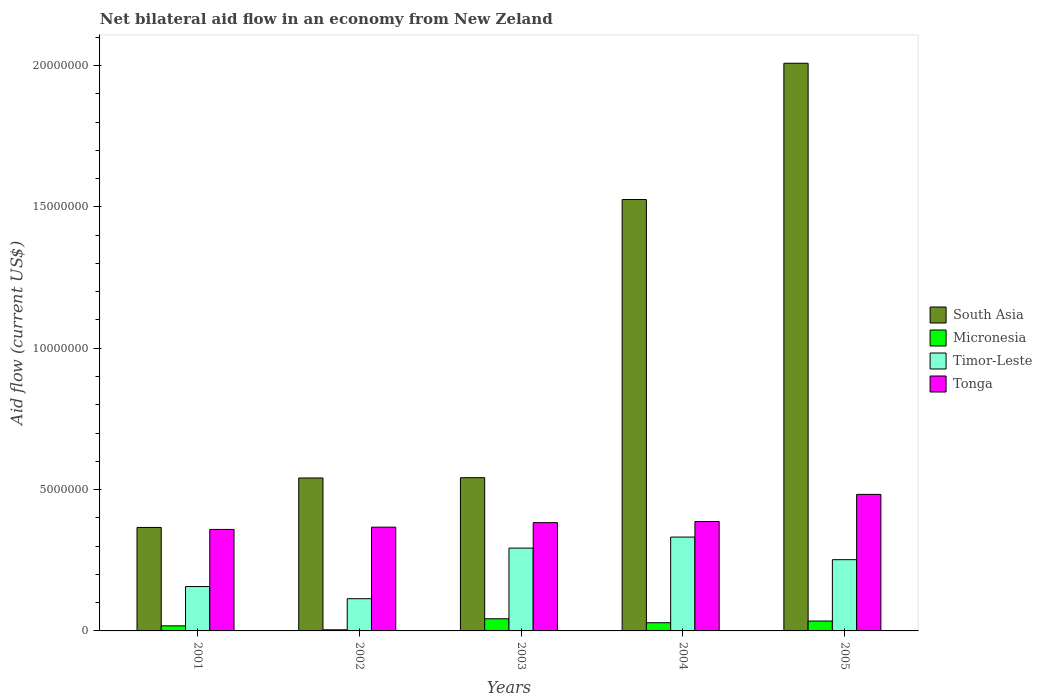How many different coloured bars are there?
Keep it short and to the point. 4. Are the number of bars per tick equal to the number of legend labels?
Keep it short and to the point. Yes. Are the number of bars on each tick of the X-axis equal?
Your answer should be compact. Yes. What is the net bilateral aid flow in South Asia in 2004?
Offer a very short reply. 1.53e+07. Across all years, what is the maximum net bilateral aid flow in South Asia?
Your answer should be very brief. 2.01e+07. Across all years, what is the minimum net bilateral aid flow in Micronesia?
Offer a very short reply. 4.00e+04. In which year was the net bilateral aid flow in Tonga maximum?
Provide a succinct answer. 2005. What is the total net bilateral aid flow in Micronesia in the graph?
Provide a succinct answer. 1.29e+06. What is the difference between the net bilateral aid flow in Tonga in 2002 and that in 2005?
Give a very brief answer. -1.16e+06. What is the difference between the net bilateral aid flow in Timor-Leste in 2001 and the net bilateral aid flow in Tonga in 2002?
Offer a very short reply. -2.10e+06. What is the average net bilateral aid flow in Tonga per year?
Keep it short and to the point. 3.96e+06. In the year 2005, what is the difference between the net bilateral aid flow in South Asia and net bilateral aid flow in Micronesia?
Provide a short and direct response. 1.97e+07. In how many years, is the net bilateral aid flow in Micronesia greater than 20000000 US$?
Your answer should be compact. 0. What is the ratio of the net bilateral aid flow in Tonga in 2001 to that in 2002?
Provide a succinct answer. 0.98. Is the net bilateral aid flow in Timor-Leste in 2001 less than that in 2003?
Provide a short and direct response. Yes. What is the difference between the highest and the second highest net bilateral aid flow in South Asia?
Provide a short and direct response. 4.82e+06. What is the difference between the highest and the lowest net bilateral aid flow in Tonga?
Make the answer very short. 1.24e+06. What does the 3rd bar from the left in 2003 represents?
Ensure brevity in your answer.  Timor-Leste. Is it the case that in every year, the sum of the net bilateral aid flow in South Asia and net bilateral aid flow in Tonga is greater than the net bilateral aid flow in Micronesia?
Provide a succinct answer. Yes. Are all the bars in the graph horizontal?
Your answer should be very brief. No. How many years are there in the graph?
Your response must be concise. 5. Are the values on the major ticks of Y-axis written in scientific E-notation?
Provide a succinct answer. No. How are the legend labels stacked?
Your answer should be compact. Vertical. What is the title of the graph?
Keep it short and to the point. Net bilateral aid flow in an economy from New Zeland. What is the label or title of the Y-axis?
Your answer should be very brief. Aid flow (current US$). What is the Aid flow (current US$) in South Asia in 2001?
Keep it short and to the point. 3.66e+06. What is the Aid flow (current US$) of Micronesia in 2001?
Give a very brief answer. 1.80e+05. What is the Aid flow (current US$) in Timor-Leste in 2001?
Provide a short and direct response. 1.57e+06. What is the Aid flow (current US$) in Tonga in 2001?
Offer a terse response. 3.59e+06. What is the Aid flow (current US$) of South Asia in 2002?
Give a very brief answer. 5.41e+06. What is the Aid flow (current US$) in Micronesia in 2002?
Give a very brief answer. 4.00e+04. What is the Aid flow (current US$) of Timor-Leste in 2002?
Your answer should be compact. 1.14e+06. What is the Aid flow (current US$) in Tonga in 2002?
Provide a succinct answer. 3.67e+06. What is the Aid flow (current US$) in South Asia in 2003?
Provide a short and direct response. 5.42e+06. What is the Aid flow (current US$) in Timor-Leste in 2003?
Make the answer very short. 2.93e+06. What is the Aid flow (current US$) of Tonga in 2003?
Make the answer very short. 3.83e+06. What is the Aid flow (current US$) in South Asia in 2004?
Provide a short and direct response. 1.53e+07. What is the Aid flow (current US$) in Timor-Leste in 2004?
Your answer should be very brief. 3.32e+06. What is the Aid flow (current US$) of Tonga in 2004?
Your answer should be very brief. 3.87e+06. What is the Aid flow (current US$) of South Asia in 2005?
Offer a very short reply. 2.01e+07. What is the Aid flow (current US$) of Timor-Leste in 2005?
Your response must be concise. 2.52e+06. What is the Aid flow (current US$) of Tonga in 2005?
Make the answer very short. 4.83e+06. Across all years, what is the maximum Aid flow (current US$) of South Asia?
Offer a very short reply. 2.01e+07. Across all years, what is the maximum Aid flow (current US$) of Timor-Leste?
Offer a very short reply. 3.32e+06. Across all years, what is the maximum Aid flow (current US$) of Tonga?
Give a very brief answer. 4.83e+06. Across all years, what is the minimum Aid flow (current US$) in South Asia?
Ensure brevity in your answer.  3.66e+06. Across all years, what is the minimum Aid flow (current US$) of Timor-Leste?
Offer a very short reply. 1.14e+06. Across all years, what is the minimum Aid flow (current US$) of Tonga?
Make the answer very short. 3.59e+06. What is the total Aid flow (current US$) of South Asia in the graph?
Your answer should be compact. 4.98e+07. What is the total Aid flow (current US$) of Micronesia in the graph?
Keep it short and to the point. 1.29e+06. What is the total Aid flow (current US$) of Timor-Leste in the graph?
Your answer should be very brief. 1.15e+07. What is the total Aid flow (current US$) of Tonga in the graph?
Offer a very short reply. 1.98e+07. What is the difference between the Aid flow (current US$) in South Asia in 2001 and that in 2002?
Your response must be concise. -1.75e+06. What is the difference between the Aid flow (current US$) of Micronesia in 2001 and that in 2002?
Your response must be concise. 1.40e+05. What is the difference between the Aid flow (current US$) in Tonga in 2001 and that in 2002?
Your answer should be compact. -8.00e+04. What is the difference between the Aid flow (current US$) of South Asia in 2001 and that in 2003?
Your answer should be very brief. -1.76e+06. What is the difference between the Aid flow (current US$) in Timor-Leste in 2001 and that in 2003?
Your answer should be very brief. -1.36e+06. What is the difference between the Aid flow (current US$) in Tonga in 2001 and that in 2003?
Make the answer very short. -2.40e+05. What is the difference between the Aid flow (current US$) of South Asia in 2001 and that in 2004?
Your answer should be compact. -1.16e+07. What is the difference between the Aid flow (current US$) of Micronesia in 2001 and that in 2004?
Give a very brief answer. -1.10e+05. What is the difference between the Aid flow (current US$) in Timor-Leste in 2001 and that in 2004?
Ensure brevity in your answer.  -1.75e+06. What is the difference between the Aid flow (current US$) in Tonga in 2001 and that in 2004?
Your answer should be compact. -2.80e+05. What is the difference between the Aid flow (current US$) in South Asia in 2001 and that in 2005?
Ensure brevity in your answer.  -1.64e+07. What is the difference between the Aid flow (current US$) of Timor-Leste in 2001 and that in 2005?
Provide a succinct answer. -9.50e+05. What is the difference between the Aid flow (current US$) in Tonga in 2001 and that in 2005?
Give a very brief answer. -1.24e+06. What is the difference between the Aid flow (current US$) of Micronesia in 2002 and that in 2003?
Offer a terse response. -3.90e+05. What is the difference between the Aid flow (current US$) of Timor-Leste in 2002 and that in 2003?
Provide a succinct answer. -1.79e+06. What is the difference between the Aid flow (current US$) of South Asia in 2002 and that in 2004?
Make the answer very short. -9.85e+06. What is the difference between the Aid flow (current US$) in Micronesia in 2002 and that in 2004?
Keep it short and to the point. -2.50e+05. What is the difference between the Aid flow (current US$) of Timor-Leste in 2002 and that in 2004?
Give a very brief answer. -2.18e+06. What is the difference between the Aid flow (current US$) in South Asia in 2002 and that in 2005?
Offer a very short reply. -1.47e+07. What is the difference between the Aid flow (current US$) of Micronesia in 2002 and that in 2005?
Make the answer very short. -3.10e+05. What is the difference between the Aid flow (current US$) in Timor-Leste in 2002 and that in 2005?
Offer a very short reply. -1.38e+06. What is the difference between the Aid flow (current US$) in Tonga in 2002 and that in 2005?
Provide a short and direct response. -1.16e+06. What is the difference between the Aid flow (current US$) in South Asia in 2003 and that in 2004?
Your response must be concise. -9.84e+06. What is the difference between the Aid flow (current US$) of Timor-Leste in 2003 and that in 2004?
Your answer should be compact. -3.90e+05. What is the difference between the Aid flow (current US$) of South Asia in 2003 and that in 2005?
Provide a short and direct response. -1.47e+07. What is the difference between the Aid flow (current US$) of Micronesia in 2003 and that in 2005?
Make the answer very short. 8.00e+04. What is the difference between the Aid flow (current US$) of Tonga in 2003 and that in 2005?
Give a very brief answer. -1.00e+06. What is the difference between the Aid flow (current US$) in South Asia in 2004 and that in 2005?
Give a very brief answer. -4.82e+06. What is the difference between the Aid flow (current US$) in Micronesia in 2004 and that in 2005?
Offer a very short reply. -6.00e+04. What is the difference between the Aid flow (current US$) in Timor-Leste in 2004 and that in 2005?
Offer a terse response. 8.00e+05. What is the difference between the Aid flow (current US$) in Tonga in 2004 and that in 2005?
Make the answer very short. -9.60e+05. What is the difference between the Aid flow (current US$) of South Asia in 2001 and the Aid flow (current US$) of Micronesia in 2002?
Offer a very short reply. 3.62e+06. What is the difference between the Aid flow (current US$) in South Asia in 2001 and the Aid flow (current US$) in Timor-Leste in 2002?
Ensure brevity in your answer.  2.52e+06. What is the difference between the Aid flow (current US$) in Micronesia in 2001 and the Aid flow (current US$) in Timor-Leste in 2002?
Offer a very short reply. -9.60e+05. What is the difference between the Aid flow (current US$) of Micronesia in 2001 and the Aid flow (current US$) of Tonga in 2002?
Provide a succinct answer. -3.49e+06. What is the difference between the Aid flow (current US$) of Timor-Leste in 2001 and the Aid flow (current US$) of Tonga in 2002?
Ensure brevity in your answer.  -2.10e+06. What is the difference between the Aid flow (current US$) in South Asia in 2001 and the Aid flow (current US$) in Micronesia in 2003?
Keep it short and to the point. 3.23e+06. What is the difference between the Aid flow (current US$) of South Asia in 2001 and the Aid flow (current US$) of Timor-Leste in 2003?
Ensure brevity in your answer.  7.30e+05. What is the difference between the Aid flow (current US$) of Micronesia in 2001 and the Aid flow (current US$) of Timor-Leste in 2003?
Your answer should be very brief. -2.75e+06. What is the difference between the Aid flow (current US$) in Micronesia in 2001 and the Aid flow (current US$) in Tonga in 2003?
Keep it short and to the point. -3.65e+06. What is the difference between the Aid flow (current US$) in Timor-Leste in 2001 and the Aid flow (current US$) in Tonga in 2003?
Your answer should be compact. -2.26e+06. What is the difference between the Aid flow (current US$) of South Asia in 2001 and the Aid flow (current US$) of Micronesia in 2004?
Your answer should be compact. 3.37e+06. What is the difference between the Aid flow (current US$) in South Asia in 2001 and the Aid flow (current US$) in Timor-Leste in 2004?
Offer a very short reply. 3.40e+05. What is the difference between the Aid flow (current US$) in Micronesia in 2001 and the Aid flow (current US$) in Timor-Leste in 2004?
Your answer should be very brief. -3.14e+06. What is the difference between the Aid flow (current US$) of Micronesia in 2001 and the Aid flow (current US$) of Tonga in 2004?
Give a very brief answer. -3.69e+06. What is the difference between the Aid flow (current US$) of Timor-Leste in 2001 and the Aid flow (current US$) of Tonga in 2004?
Your answer should be very brief. -2.30e+06. What is the difference between the Aid flow (current US$) in South Asia in 2001 and the Aid flow (current US$) in Micronesia in 2005?
Offer a very short reply. 3.31e+06. What is the difference between the Aid flow (current US$) in South Asia in 2001 and the Aid flow (current US$) in Timor-Leste in 2005?
Make the answer very short. 1.14e+06. What is the difference between the Aid flow (current US$) in South Asia in 2001 and the Aid flow (current US$) in Tonga in 2005?
Give a very brief answer. -1.17e+06. What is the difference between the Aid flow (current US$) in Micronesia in 2001 and the Aid flow (current US$) in Timor-Leste in 2005?
Your answer should be very brief. -2.34e+06. What is the difference between the Aid flow (current US$) of Micronesia in 2001 and the Aid flow (current US$) of Tonga in 2005?
Keep it short and to the point. -4.65e+06. What is the difference between the Aid flow (current US$) of Timor-Leste in 2001 and the Aid flow (current US$) of Tonga in 2005?
Your response must be concise. -3.26e+06. What is the difference between the Aid flow (current US$) of South Asia in 2002 and the Aid flow (current US$) of Micronesia in 2003?
Your answer should be compact. 4.98e+06. What is the difference between the Aid flow (current US$) of South Asia in 2002 and the Aid flow (current US$) of Timor-Leste in 2003?
Your response must be concise. 2.48e+06. What is the difference between the Aid flow (current US$) of South Asia in 2002 and the Aid flow (current US$) of Tonga in 2003?
Offer a very short reply. 1.58e+06. What is the difference between the Aid flow (current US$) of Micronesia in 2002 and the Aid flow (current US$) of Timor-Leste in 2003?
Offer a very short reply. -2.89e+06. What is the difference between the Aid flow (current US$) in Micronesia in 2002 and the Aid flow (current US$) in Tonga in 2003?
Your response must be concise. -3.79e+06. What is the difference between the Aid flow (current US$) of Timor-Leste in 2002 and the Aid flow (current US$) of Tonga in 2003?
Your response must be concise. -2.69e+06. What is the difference between the Aid flow (current US$) in South Asia in 2002 and the Aid flow (current US$) in Micronesia in 2004?
Offer a very short reply. 5.12e+06. What is the difference between the Aid flow (current US$) in South Asia in 2002 and the Aid flow (current US$) in Timor-Leste in 2004?
Ensure brevity in your answer.  2.09e+06. What is the difference between the Aid flow (current US$) of South Asia in 2002 and the Aid flow (current US$) of Tonga in 2004?
Your answer should be compact. 1.54e+06. What is the difference between the Aid flow (current US$) in Micronesia in 2002 and the Aid flow (current US$) in Timor-Leste in 2004?
Provide a succinct answer. -3.28e+06. What is the difference between the Aid flow (current US$) of Micronesia in 2002 and the Aid flow (current US$) of Tonga in 2004?
Ensure brevity in your answer.  -3.83e+06. What is the difference between the Aid flow (current US$) of Timor-Leste in 2002 and the Aid flow (current US$) of Tonga in 2004?
Make the answer very short. -2.73e+06. What is the difference between the Aid flow (current US$) of South Asia in 2002 and the Aid flow (current US$) of Micronesia in 2005?
Offer a very short reply. 5.06e+06. What is the difference between the Aid flow (current US$) of South Asia in 2002 and the Aid flow (current US$) of Timor-Leste in 2005?
Offer a terse response. 2.89e+06. What is the difference between the Aid flow (current US$) of South Asia in 2002 and the Aid flow (current US$) of Tonga in 2005?
Your answer should be compact. 5.80e+05. What is the difference between the Aid flow (current US$) in Micronesia in 2002 and the Aid flow (current US$) in Timor-Leste in 2005?
Ensure brevity in your answer.  -2.48e+06. What is the difference between the Aid flow (current US$) of Micronesia in 2002 and the Aid flow (current US$) of Tonga in 2005?
Keep it short and to the point. -4.79e+06. What is the difference between the Aid flow (current US$) in Timor-Leste in 2002 and the Aid flow (current US$) in Tonga in 2005?
Your response must be concise. -3.69e+06. What is the difference between the Aid flow (current US$) of South Asia in 2003 and the Aid flow (current US$) of Micronesia in 2004?
Provide a short and direct response. 5.13e+06. What is the difference between the Aid flow (current US$) of South Asia in 2003 and the Aid flow (current US$) of Timor-Leste in 2004?
Make the answer very short. 2.10e+06. What is the difference between the Aid flow (current US$) of South Asia in 2003 and the Aid flow (current US$) of Tonga in 2004?
Offer a terse response. 1.55e+06. What is the difference between the Aid flow (current US$) of Micronesia in 2003 and the Aid flow (current US$) of Timor-Leste in 2004?
Provide a short and direct response. -2.89e+06. What is the difference between the Aid flow (current US$) in Micronesia in 2003 and the Aid flow (current US$) in Tonga in 2004?
Offer a terse response. -3.44e+06. What is the difference between the Aid flow (current US$) in Timor-Leste in 2003 and the Aid flow (current US$) in Tonga in 2004?
Give a very brief answer. -9.40e+05. What is the difference between the Aid flow (current US$) of South Asia in 2003 and the Aid flow (current US$) of Micronesia in 2005?
Provide a succinct answer. 5.07e+06. What is the difference between the Aid flow (current US$) of South Asia in 2003 and the Aid flow (current US$) of Timor-Leste in 2005?
Offer a very short reply. 2.90e+06. What is the difference between the Aid flow (current US$) in South Asia in 2003 and the Aid flow (current US$) in Tonga in 2005?
Your response must be concise. 5.90e+05. What is the difference between the Aid flow (current US$) in Micronesia in 2003 and the Aid flow (current US$) in Timor-Leste in 2005?
Keep it short and to the point. -2.09e+06. What is the difference between the Aid flow (current US$) in Micronesia in 2003 and the Aid flow (current US$) in Tonga in 2005?
Make the answer very short. -4.40e+06. What is the difference between the Aid flow (current US$) of Timor-Leste in 2003 and the Aid flow (current US$) of Tonga in 2005?
Offer a very short reply. -1.90e+06. What is the difference between the Aid flow (current US$) in South Asia in 2004 and the Aid flow (current US$) in Micronesia in 2005?
Give a very brief answer. 1.49e+07. What is the difference between the Aid flow (current US$) in South Asia in 2004 and the Aid flow (current US$) in Timor-Leste in 2005?
Your answer should be compact. 1.27e+07. What is the difference between the Aid flow (current US$) of South Asia in 2004 and the Aid flow (current US$) of Tonga in 2005?
Your answer should be compact. 1.04e+07. What is the difference between the Aid flow (current US$) of Micronesia in 2004 and the Aid flow (current US$) of Timor-Leste in 2005?
Provide a succinct answer. -2.23e+06. What is the difference between the Aid flow (current US$) in Micronesia in 2004 and the Aid flow (current US$) in Tonga in 2005?
Keep it short and to the point. -4.54e+06. What is the difference between the Aid flow (current US$) in Timor-Leste in 2004 and the Aid flow (current US$) in Tonga in 2005?
Your response must be concise. -1.51e+06. What is the average Aid flow (current US$) of South Asia per year?
Offer a very short reply. 9.97e+06. What is the average Aid flow (current US$) in Micronesia per year?
Your answer should be very brief. 2.58e+05. What is the average Aid flow (current US$) of Timor-Leste per year?
Keep it short and to the point. 2.30e+06. What is the average Aid flow (current US$) in Tonga per year?
Provide a short and direct response. 3.96e+06. In the year 2001, what is the difference between the Aid flow (current US$) of South Asia and Aid flow (current US$) of Micronesia?
Provide a succinct answer. 3.48e+06. In the year 2001, what is the difference between the Aid flow (current US$) of South Asia and Aid flow (current US$) of Timor-Leste?
Provide a short and direct response. 2.09e+06. In the year 2001, what is the difference between the Aid flow (current US$) of Micronesia and Aid flow (current US$) of Timor-Leste?
Give a very brief answer. -1.39e+06. In the year 2001, what is the difference between the Aid flow (current US$) in Micronesia and Aid flow (current US$) in Tonga?
Provide a succinct answer. -3.41e+06. In the year 2001, what is the difference between the Aid flow (current US$) in Timor-Leste and Aid flow (current US$) in Tonga?
Your response must be concise. -2.02e+06. In the year 2002, what is the difference between the Aid flow (current US$) of South Asia and Aid flow (current US$) of Micronesia?
Your answer should be compact. 5.37e+06. In the year 2002, what is the difference between the Aid flow (current US$) in South Asia and Aid flow (current US$) in Timor-Leste?
Provide a short and direct response. 4.27e+06. In the year 2002, what is the difference between the Aid flow (current US$) of South Asia and Aid flow (current US$) of Tonga?
Offer a terse response. 1.74e+06. In the year 2002, what is the difference between the Aid flow (current US$) in Micronesia and Aid flow (current US$) in Timor-Leste?
Make the answer very short. -1.10e+06. In the year 2002, what is the difference between the Aid flow (current US$) of Micronesia and Aid flow (current US$) of Tonga?
Your answer should be compact. -3.63e+06. In the year 2002, what is the difference between the Aid flow (current US$) of Timor-Leste and Aid flow (current US$) of Tonga?
Provide a short and direct response. -2.53e+06. In the year 2003, what is the difference between the Aid flow (current US$) of South Asia and Aid flow (current US$) of Micronesia?
Offer a very short reply. 4.99e+06. In the year 2003, what is the difference between the Aid flow (current US$) of South Asia and Aid flow (current US$) of Timor-Leste?
Offer a terse response. 2.49e+06. In the year 2003, what is the difference between the Aid flow (current US$) in South Asia and Aid flow (current US$) in Tonga?
Give a very brief answer. 1.59e+06. In the year 2003, what is the difference between the Aid flow (current US$) in Micronesia and Aid flow (current US$) in Timor-Leste?
Offer a very short reply. -2.50e+06. In the year 2003, what is the difference between the Aid flow (current US$) of Micronesia and Aid flow (current US$) of Tonga?
Your answer should be compact. -3.40e+06. In the year 2003, what is the difference between the Aid flow (current US$) of Timor-Leste and Aid flow (current US$) of Tonga?
Ensure brevity in your answer.  -9.00e+05. In the year 2004, what is the difference between the Aid flow (current US$) of South Asia and Aid flow (current US$) of Micronesia?
Your response must be concise. 1.50e+07. In the year 2004, what is the difference between the Aid flow (current US$) in South Asia and Aid flow (current US$) in Timor-Leste?
Provide a succinct answer. 1.19e+07. In the year 2004, what is the difference between the Aid flow (current US$) of South Asia and Aid flow (current US$) of Tonga?
Provide a short and direct response. 1.14e+07. In the year 2004, what is the difference between the Aid flow (current US$) in Micronesia and Aid flow (current US$) in Timor-Leste?
Your response must be concise. -3.03e+06. In the year 2004, what is the difference between the Aid flow (current US$) of Micronesia and Aid flow (current US$) of Tonga?
Offer a terse response. -3.58e+06. In the year 2004, what is the difference between the Aid flow (current US$) of Timor-Leste and Aid flow (current US$) of Tonga?
Your answer should be compact. -5.50e+05. In the year 2005, what is the difference between the Aid flow (current US$) in South Asia and Aid flow (current US$) in Micronesia?
Provide a short and direct response. 1.97e+07. In the year 2005, what is the difference between the Aid flow (current US$) of South Asia and Aid flow (current US$) of Timor-Leste?
Give a very brief answer. 1.76e+07. In the year 2005, what is the difference between the Aid flow (current US$) of South Asia and Aid flow (current US$) of Tonga?
Ensure brevity in your answer.  1.52e+07. In the year 2005, what is the difference between the Aid flow (current US$) of Micronesia and Aid flow (current US$) of Timor-Leste?
Make the answer very short. -2.17e+06. In the year 2005, what is the difference between the Aid flow (current US$) in Micronesia and Aid flow (current US$) in Tonga?
Offer a terse response. -4.48e+06. In the year 2005, what is the difference between the Aid flow (current US$) in Timor-Leste and Aid flow (current US$) in Tonga?
Your answer should be very brief. -2.31e+06. What is the ratio of the Aid flow (current US$) of South Asia in 2001 to that in 2002?
Ensure brevity in your answer.  0.68. What is the ratio of the Aid flow (current US$) in Timor-Leste in 2001 to that in 2002?
Your response must be concise. 1.38. What is the ratio of the Aid flow (current US$) of Tonga in 2001 to that in 2002?
Your response must be concise. 0.98. What is the ratio of the Aid flow (current US$) of South Asia in 2001 to that in 2003?
Give a very brief answer. 0.68. What is the ratio of the Aid flow (current US$) in Micronesia in 2001 to that in 2003?
Your answer should be very brief. 0.42. What is the ratio of the Aid flow (current US$) in Timor-Leste in 2001 to that in 2003?
Keep it short and to the point. 0.54. What is the ratio of the Aid flow (current US$) in Tonga in 2001 to that in 2003?
Provide a short and direct response. 0.94. What is the ratio of the Aid flow (current US$) in South Asia in 2001 to that in 2004?
Your response must be concise. 0.24. What is the ratio of the Aid flow (current US$) of Micronesia in 2001 to that in 2004?
Make the answer very short. 0.62. What is the ratio of the Aid flow (current US$) in Timor-Leste in 2001 to that in 2004?
Your answer should be very brief. 0.47. What is the ratio of the Aid flow (current US$) in Tonga in 2001 to that in 2004?
Offer a very short reply. 0.93. What is the ratio of the Aid flow (current US$) of South Asia in 2001 to that in 2005?
Keep it short and to the point. 0.18. What is the ratio of the Aid flow (current US$) of Micronesia in 2001 to that in 2005?
Offer a very short reply. 0.51. What is the ratio of the Aid flow (current US$) of Timor-Leste in 2001 to that in 2005?
Provide a succinct answer. 0.62. What is the ratio of the Aid flow (current US$) in Tonga in 2001 to that in 2005?
Offer a terse response. 0.74. What is the ratio of the Aid flow (current US$) in Micronesia in 2002 to that in 2003?
Provide a succinct answer. 0.09. What is the ratio of the Aid flow (current US$) in Timor-Leste in 2002 to that in 2003?
Your answer should be compact. 0.39. What is the ratio of the Aid flow (current US$) of Tonga in 2002 to that in 2003?
Offer a very short reply. 0.96. What is the ratio of the Aid flow (current US$) of South Asia in 2002 to that in 2004?
Provide a short and direct response. 0.35. What is the ratio of the Aid flow (current US$) in Micronesia in 2002 to that in 2004?
Your answer should be very brief. 0.14. What is the ratio of the Aid flow (current US$) of Timor-Leste in 2002 to that in 2004?
Ensure brevity in your answer.  0.34. What is the ratio of the Aid flow (current US$) in Tonga in 2002 to that in 2004?
Keep it short and to the point. 0.95. What is the ratio of the Aid flow (current US$) in South Asia in 2002 to that in 2005?
Keep it short and to the point. 0.27. What is the ratio of the Aid flow (current US$) of Micronesia in 2002 to that in 2005?
Give a very brief answer. 0.11. What is the ratio of the Aid flow (current US$) of Timor-Leste in 2002 to that in 2005?
Make the answer very short. 0.45. What is the ratio of the Aid flow (current US$) of Tonga in 2002 to that in 2005?
Provide a short and direct response. 0.76. What is the ratio of the Aid flow (current US$) of South Asia in 2003 to that in 2004?
Offer a terse response. 0.36. What is the ratio of the Aid flow (current US$) of Micronesia in 2003 to that in 2004?
Your answer should be compact. 1.48. What is the ratio of the Aid flow (current US$) of Timor-Leste in 2003 to that in 2004?
Your response must be concise. 0.88. What is the ratio of the Aid flow (current US$) in Tonga in 2003 to that in 2004?
Ensure brevity in your answer.  0.99. What is the ratio of the Aid flow (current US$) in South Asia in 2003 to that in 2005?
Keep it short and to the point. 0.27. What is the ratio of the Aid flow (current US$) in Micronesia in 2003 to that in 2005?
Offer a very short reply. 1.23. What is the ratio of the Aid flow (current US$) in Timor-Leste in 2003 to that in 2005?
Keep it short and to the point. 1.16. What is the ratio of the Aid flow (current US$) of Tonga in 2003 to that in 2005?
Provide a short and direct response. 0.79. What is the ratio of the Aid flow (current US$) of South Asia in 2004 to that in 2005?
Give a very brief answer. 0.76. What is the ratio of the Aid flow (current US$) in Micronesia in 2004 to that in 2005?
Your answer should be compact. 0.83. What is the ratio of the Aid flow (current US$) of Timor-Leste in 2004 to that in 2005?
Your response must be concise. 1.32. What is the ratio of the Aid flow (current US$) in Tonga in 2004 to that in 2005?
Provide a short and direct response. 0.8. What is the difference between the highest and the second highest Aid flow (current US$) in South Asia?
Provide a short and direct response. 4.82e+06. What is the difference between the highest and the second highest Aid flow (current US$) in Micronesia?
Your response must be concise. 8.00e+04. What is the difference between the highest and the second highest Aid flow (current US$) in Tonga?
Provide a short and direct response. 9.60e+05. What is the difference between the highest and the lowest Aid flow (current US$) of South Asia?
Ensure brevity in your answer.  1.64e+07. What is the difference between the highest and the lowest Aid flow (current US$) of Timor-Leste?
Ensure brevity in your answer.  2.18e+06. What is the difference between the highest and the lowest Aid flow (current US$) in Tonga?
Your answer should be very brief. 1.24e+06. 